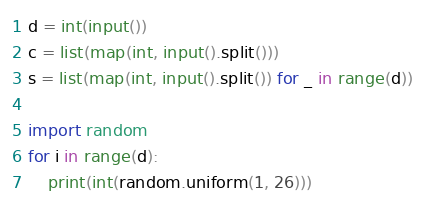<code> <loc_0><loc_0><loc_500><loc_500><_Python_>d = int(input())
c = list(map(int, input().split()))
s = list(map(int, input().split()) for _ in range(d))

import random
for i in range(d):
    print(int(random.uniform(1, 26)))</code> 